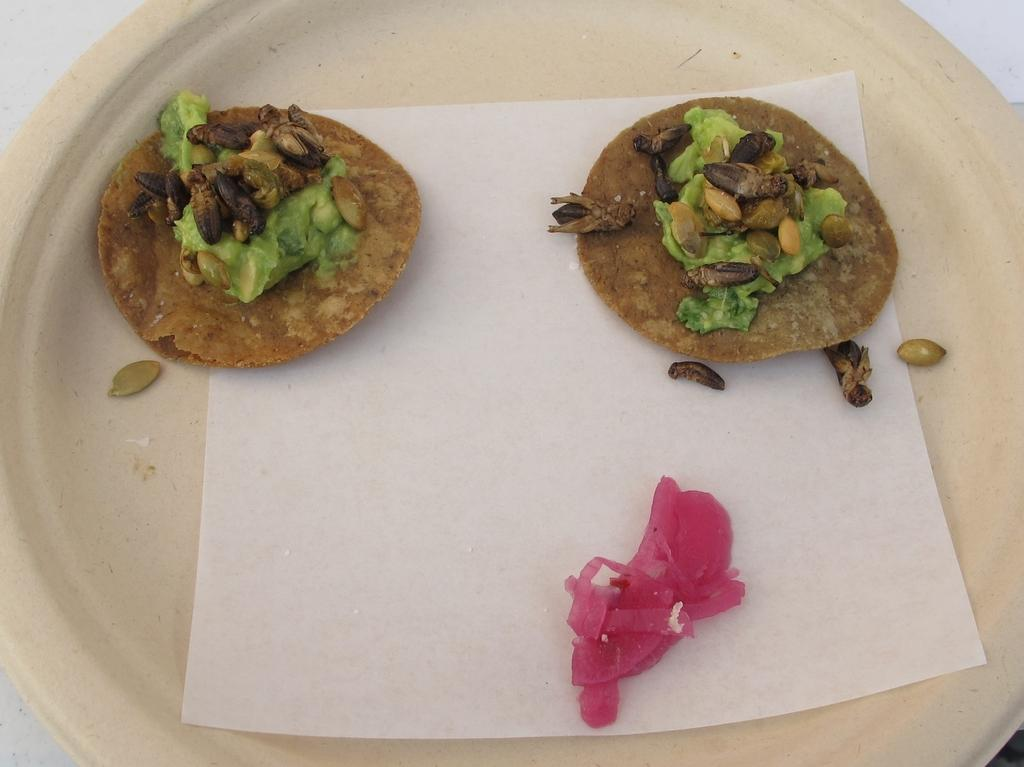What is on the plate that is visible in the image? There is a plate with food in the image. What else can be seen on the white surface in the image? There is a paper on a white surface in the image. Where is the boy sleeping in the image? There is no boy or bedroom present in the image. What type of breath can be seen coming from the paper in the image? There is no breath present in the image; it features a plate with food and a paper on a white surface. 